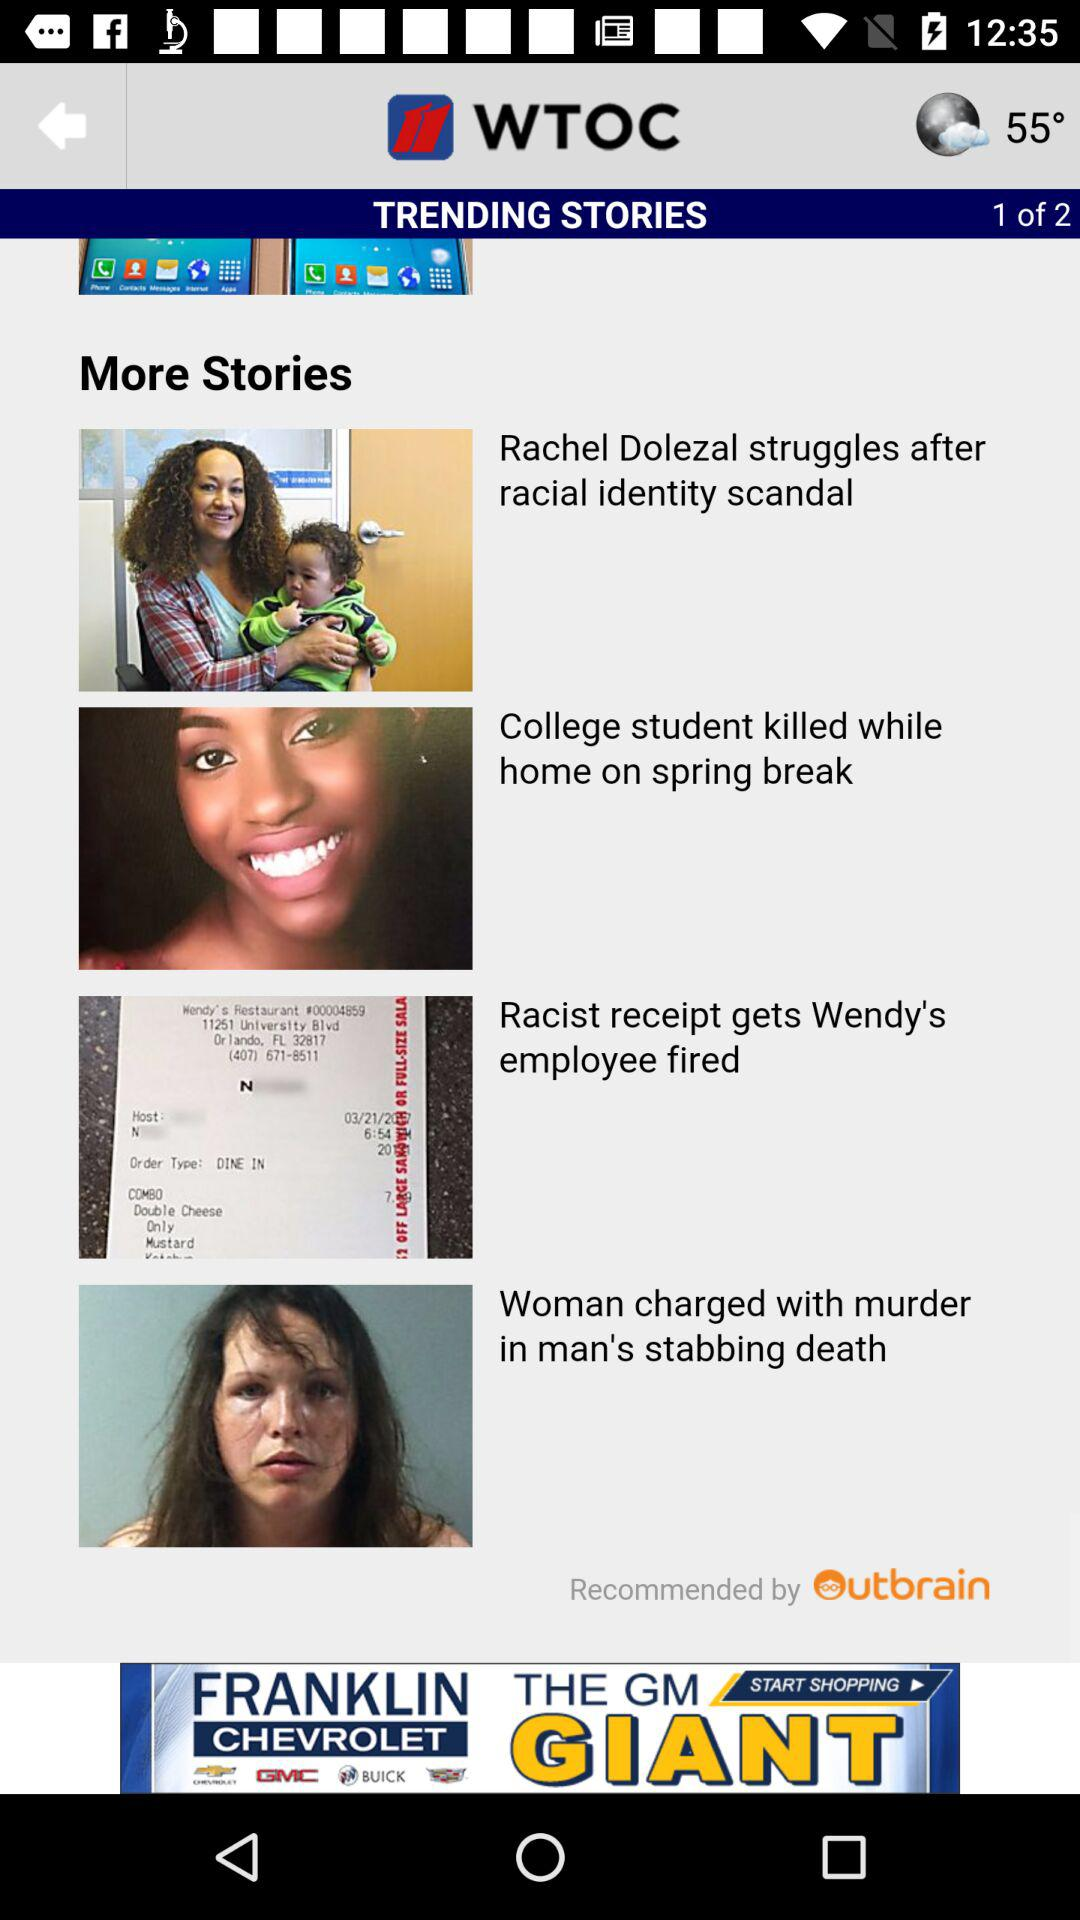What is the weather?
When the provided information is insufficient, respond with <no answer>. <no answer> 